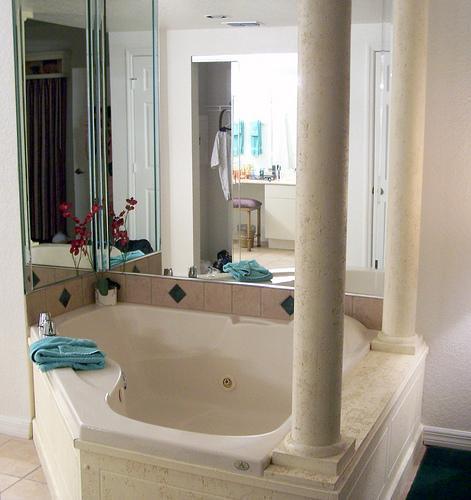What is the purpose of the round objects in the tub?
Select the accurate answer and provide explanation: 'Answer: answer
Rationale: rationale.'
Options: Drainage, massage, mood lighting, soap dispensing. Answer: massage.
Rationale: These are jets that force water out fast 